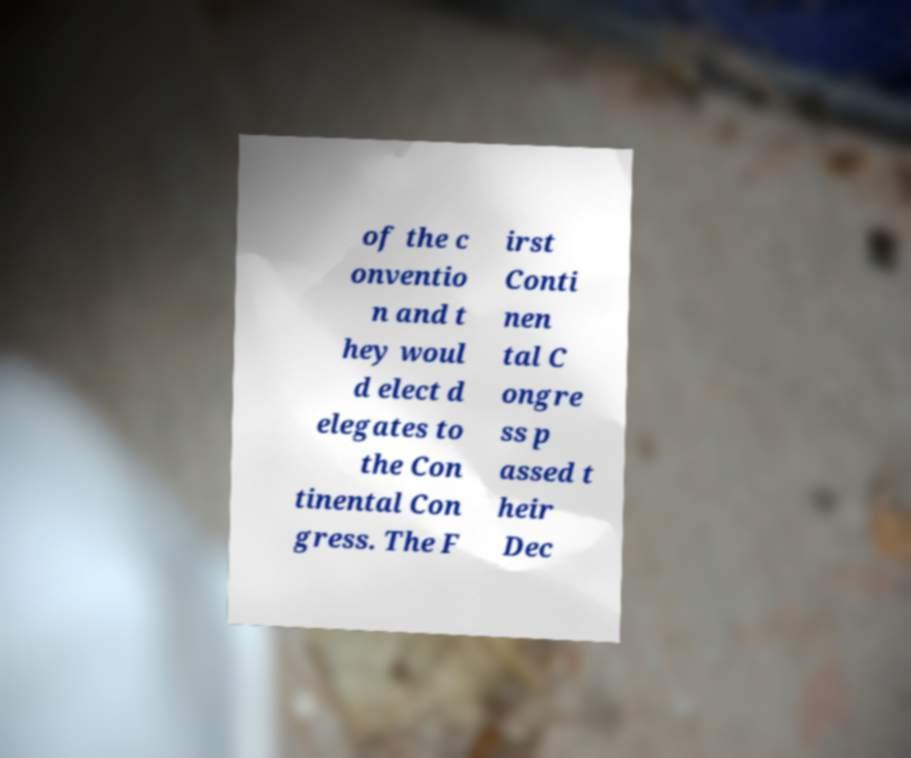Could you assist in decoding the text presented in this image and type it out clearly? of the c onventio n and t hey woul d elect d elegates to the Con tinental Con gress. The F irst Conti nen tal C ongre ss p assed t heir Dec 